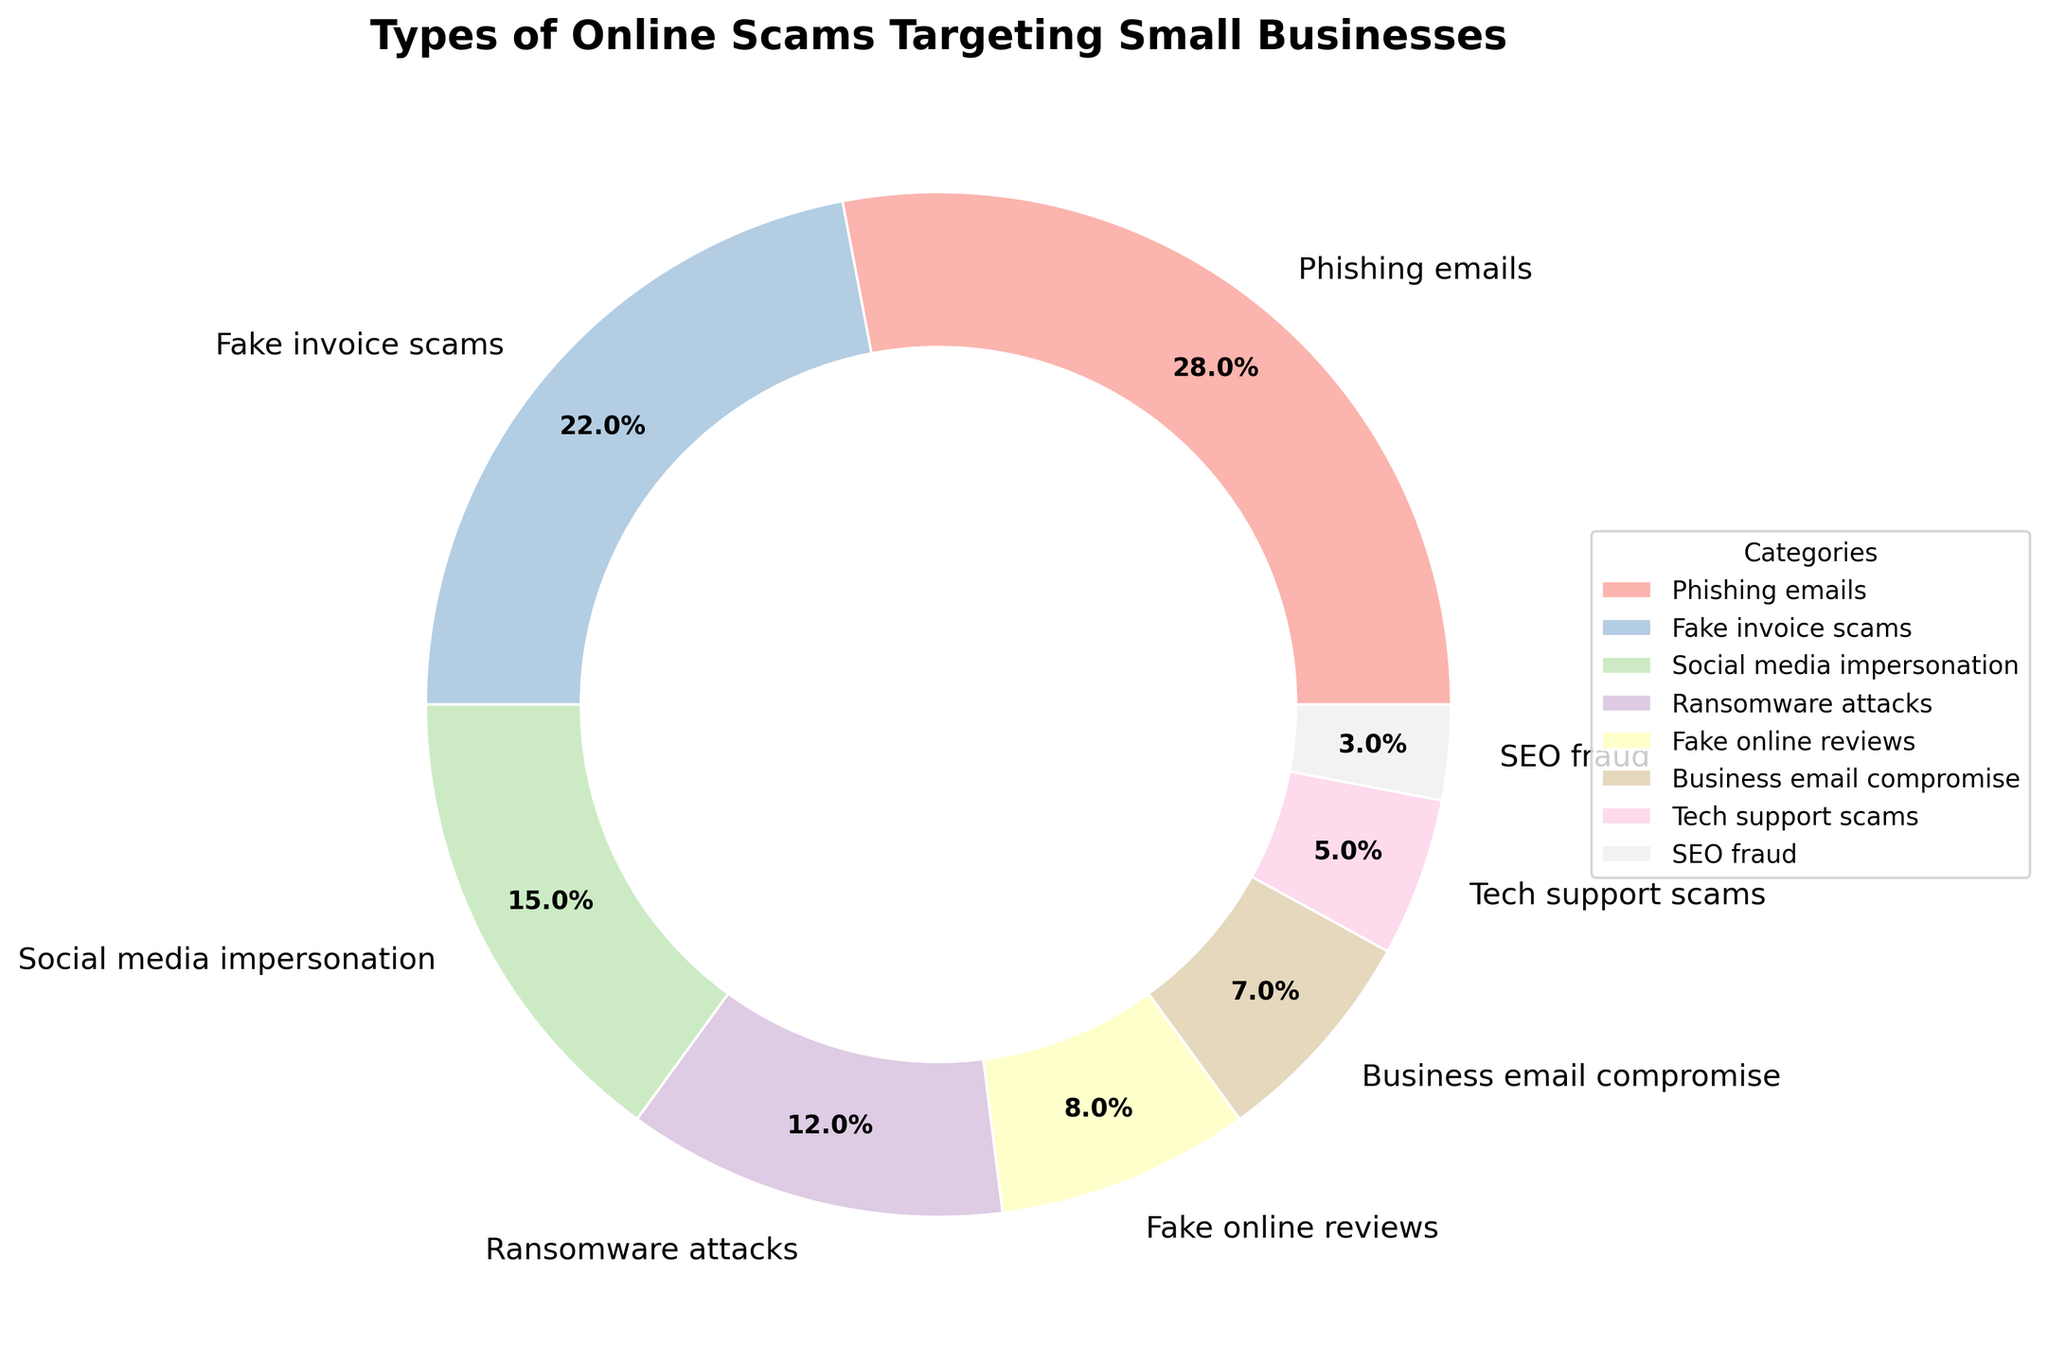what percentage of online scams is attributed to phishing emails? Look at the pie chart and find the segment labeled "Phishing emails." The corresponding percentage is shown as 28%.
Answer: 28% how much larger in percentage is ransomware attacks compared to tech support scams? Compare the two segments labeled "Ransomware attacks" and "Tech support scams." Ransomware attacks are 12%, and tech support scams are 5%. The difference is 12% - 5% = 7%.
Answer: 7% which scam method accounts for the smallest percentage and what is its value? Look at all the segments and identify the smallest one, labeled "SEO fraud," which has a percentage value of 3%.
Answer: SEO fraud: 3% what is the combined percentage of phishing emails and fake invoice scams? Add the percentages of "Phishing emails" (28%) and "Fake invoice scams" (22%). The combined value is 28% + 22% = 50%.
Answer: 50% are there any categories with equal percentages? Scan through the pie chart labels and percentages to check for equal values. No segments have equal percentages in this specific pie chart.
Answer: No what is the difference in percentage between social media impersonation and business email compromise? Find the percentages for "Social media impersonation" (15%) and "Business email compromise" (7%). The difference is 15% - 7% = 8%.
Answer: 8% which type of scam is represented by the medium purple color? Locate the segment with the medium purple color, which is labeled "Ransomware attacks" at 12%.
Answer: Ransomware attacks how many scam categories make up less than 10% each? Identify the slices in the pie chart with percentages less than 10%: "Fake online reviews," "Business email compromise," "Tech support scams," and "SEO fraud." There are 4 such categories.
Answer: 4 does fake invoice scams category have a higher or lower percentage than social media impersonation? Compare the percentage of "Fake invoice scams" (22%) with "Social media impersonation" (15%). Fake invoice scams have a higher percentage.
Answer: Higher what is the total percentage of scams represented by categories that individually are greater than or equal to 8%? Identify categories with percentages ≥ 8%: "Phishing emails" (28%), "Fake invoice scams" (22%), "Social media impersonation" (15%), "Ransomware attacks" (12%), and "Fake online reviews" (8%). Sum them: 28% + 22% + 15% + 12% + 8% = 85%.
Answer: 85% 